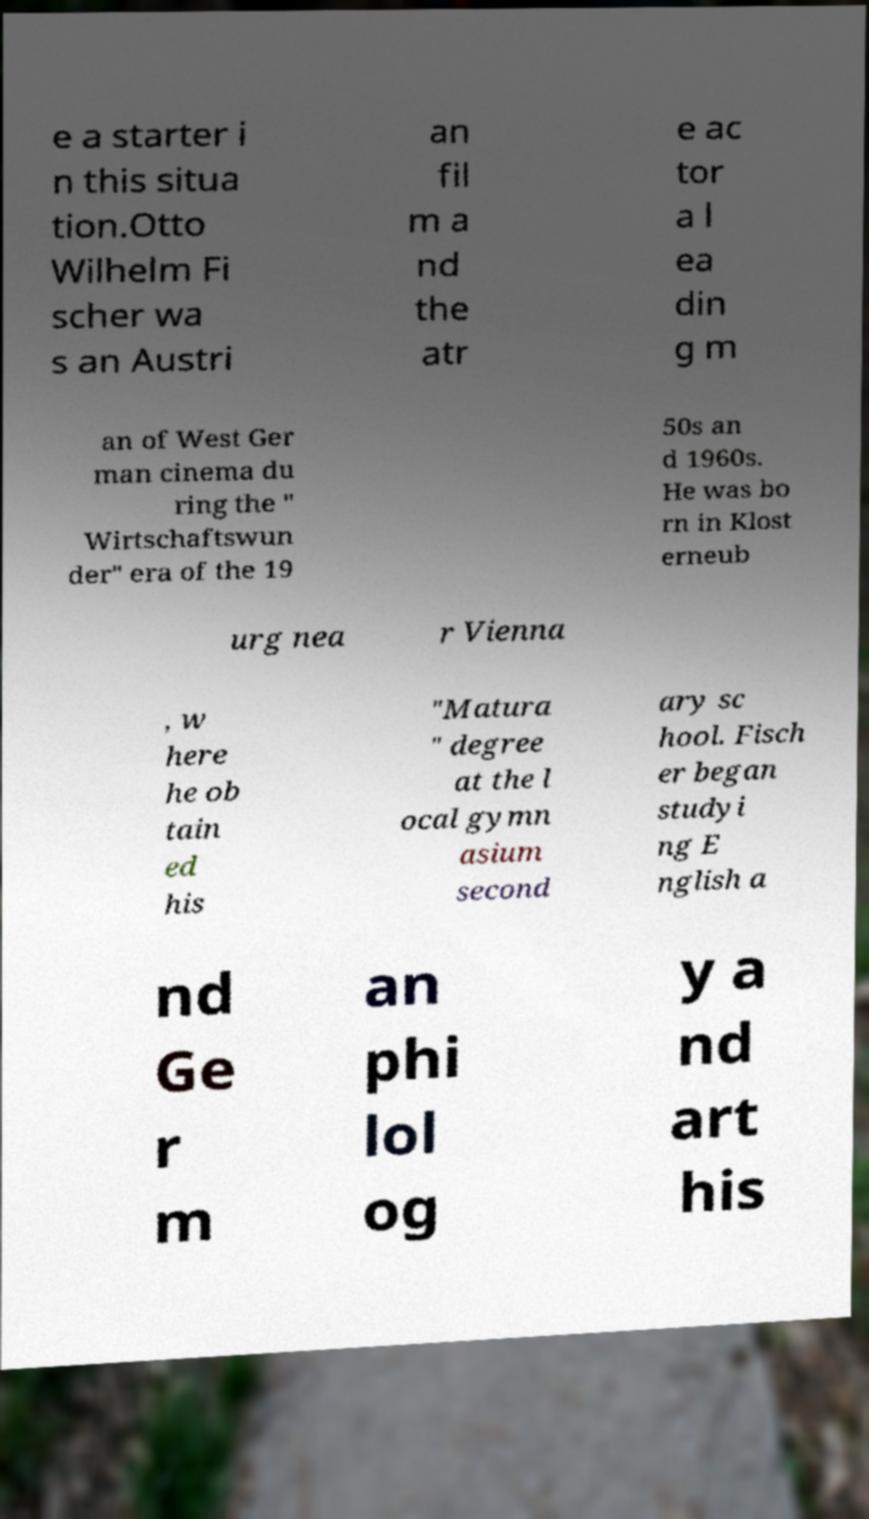Please identify and transcribe the text found in this image. e a starter i n this situa tion.Otto Wilhelm Fi scher wa s an Austri an fil m a nd the atr e ac tor a l ea din g m an of West Ger man cinema du ring the " Wirtschaftswun der" era of the 19 50s an d 1960s. He was bo rn in Klost erneub urg nea r Vienna , w here he ob tain ed his "Matura " degree at the l ocal gymn asium second ary sc hool. Fisch er began studyi ng E nglish a nd Ge r m an phi lol og y a nd art his 